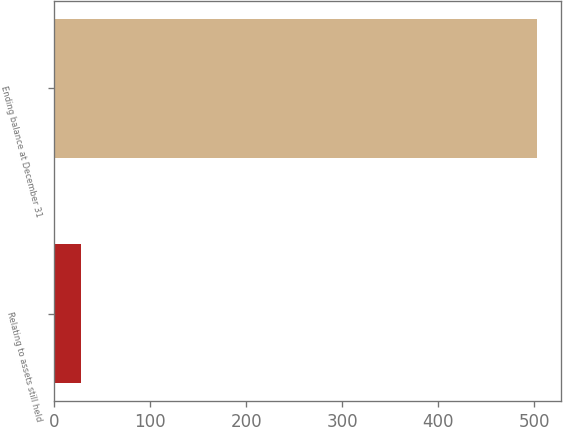Convert chart. <chart><loc_0><loc_0><loc_500><loc_500><bar_chart><fcel>Relating to assets still held<fcel>Ending balance at December 31<nl><fcel>28<fcel>503<nl></chart> 